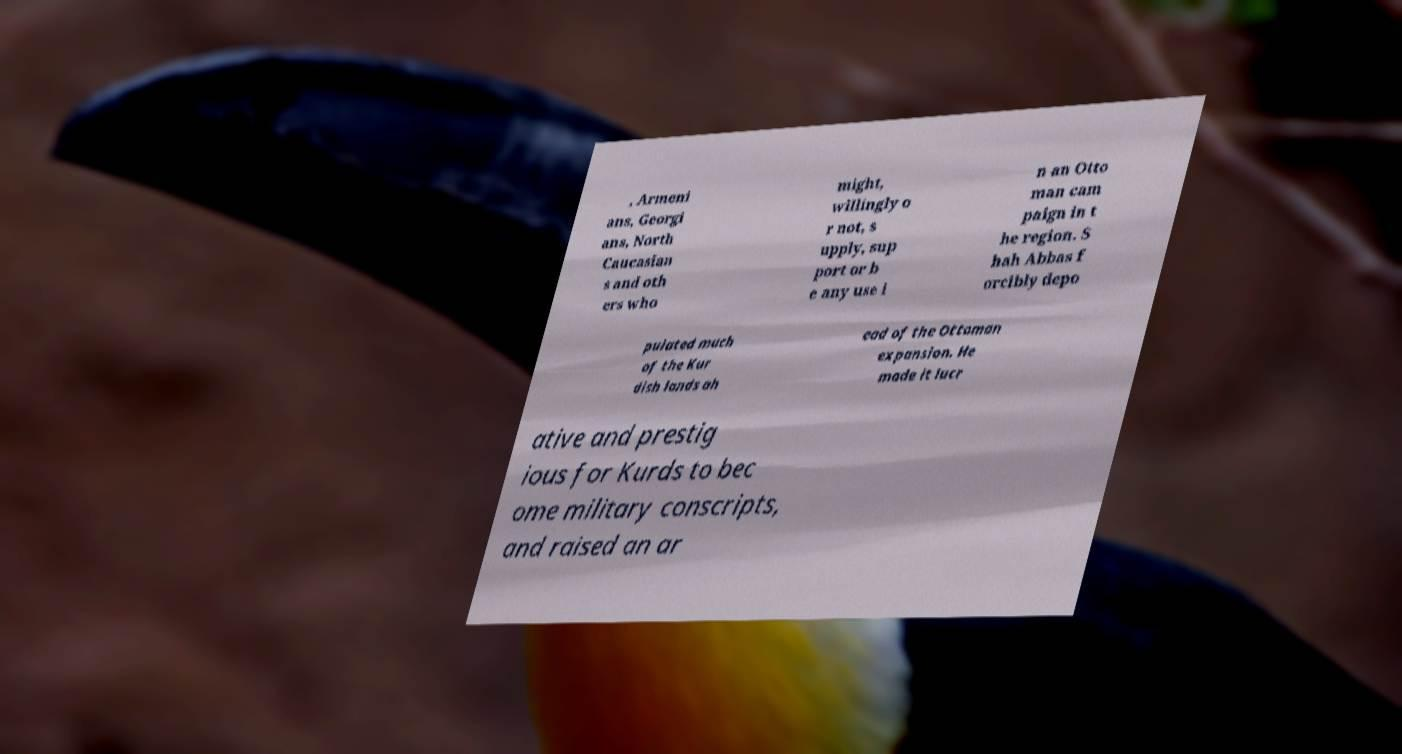I need the written content from this picture converted into text. Can you do that? , Armeni ans, Georgi ans, North Caucasian s and oth ers who might, willingly o r not, s upply, sup port or b e any use i n an Otto man cam paign in t he region. S hah Abbas f orcibly depo pulated much of the Kur dish lands ah ead of the Ottoman expansion. He made it lucr ative and prestig ious for Kurds to bec ome military conscripts, and raised an ar 